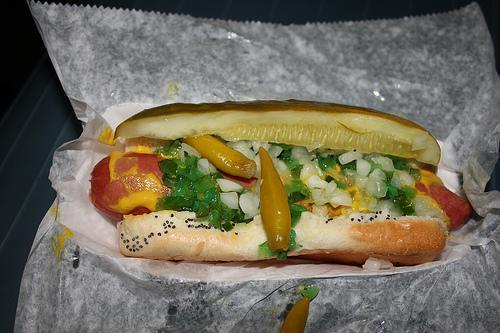How many hot dogs are there?
Give a very brief answer. 1. 